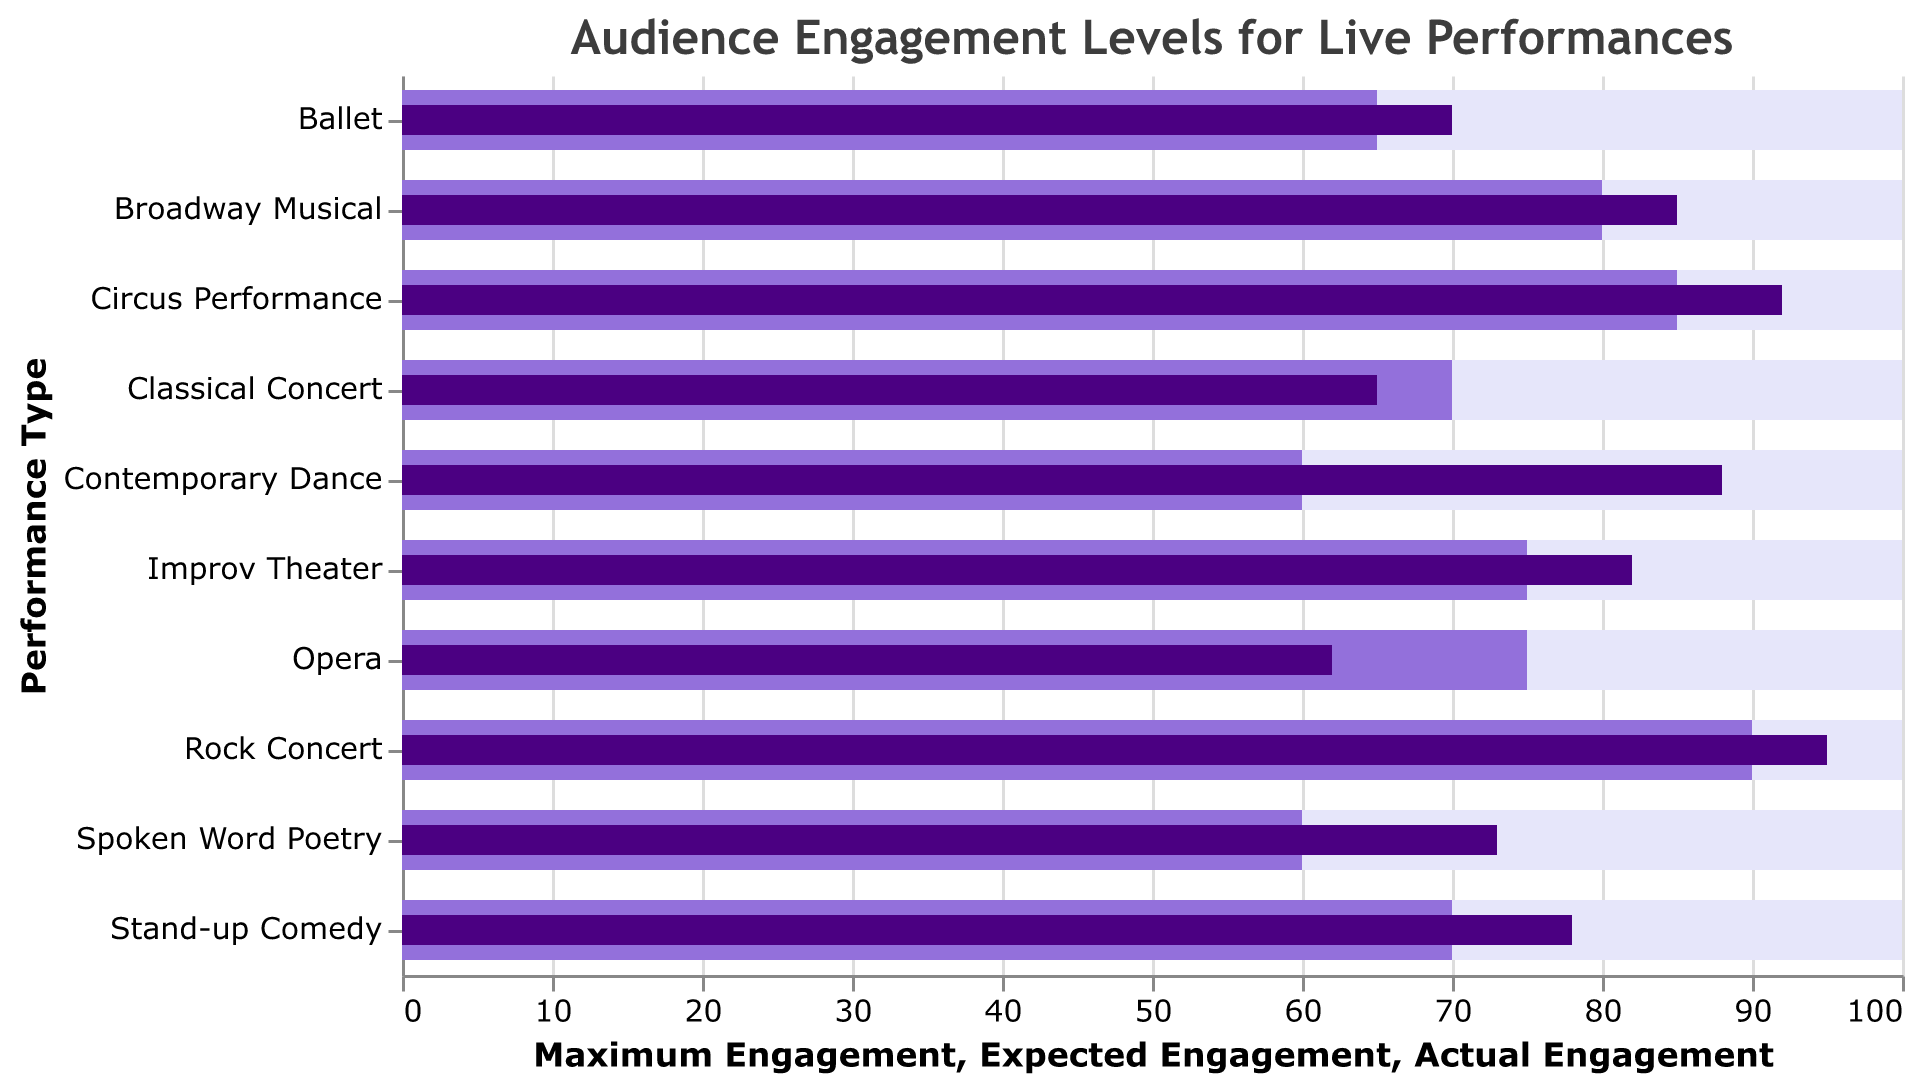what is the actual engagement level for the "Rock Concert"? Look for the "Rock Concert" bar in the figure and note the value of the "Actual Engagement" bar
Answer: 95 How many performance types exceed their expected engagement levels? Compare each performance type's actual engagement level to its expected engagement level and count the number of performance types where the actual engagement is higher
Answer: 8 What is the difference between the actual and expected engagement levels for "Opera"? Look for “Opera” and subtract the expected engagement (75) from the actual engagement (62)
Answer: 13 Which performance type has the highest actual engagement level? Compare the heights of the "Actual Engagement" bars and find the one that is the tallest
Answer: Rock Concert In which performances do the actual engagement levels fall short of the expected engagement levels? Look at each performance where the actual engagement bar is shorter than the expected engagement bar
Answer: Opera, Classical Concert Which performance type has the lowest actual engagement level? Compare the heights of the actual engagement bars and find the shortest one
Answer: Opera Between "Broadway Musical" and "Circus Performance," which has a higher expected engagement level? Look at the expected engagement bars for both performances and compare their heights
Answer: Circus Performance What is the combined actual engagement level for "Stand-up Comedy" and "Ballet"? Add the actual engagement levels of "Stand-up Comedy" (78) and "Ballet" (70)
Answer: 148 Which performance type has an actual engagement level that exactly matches its expected engagement level? Look for the performance type where the actual engagement bar aligns perfectly with the expected engagement bar
Answer: None How far is "Contemporary Dance" from reaching maximum engagement? Subtract the actual engagement level of "Contemporary Dance" (88) from the maximum engagement (100)
Answer: 12 